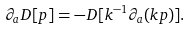<formula> <loc_0><loc_0><loc_500><loc_500>\partial _ { a } D [ p ] = - D [ k ^ { - 1 } \partial _ { a } ( k p ) ] .</formula> 